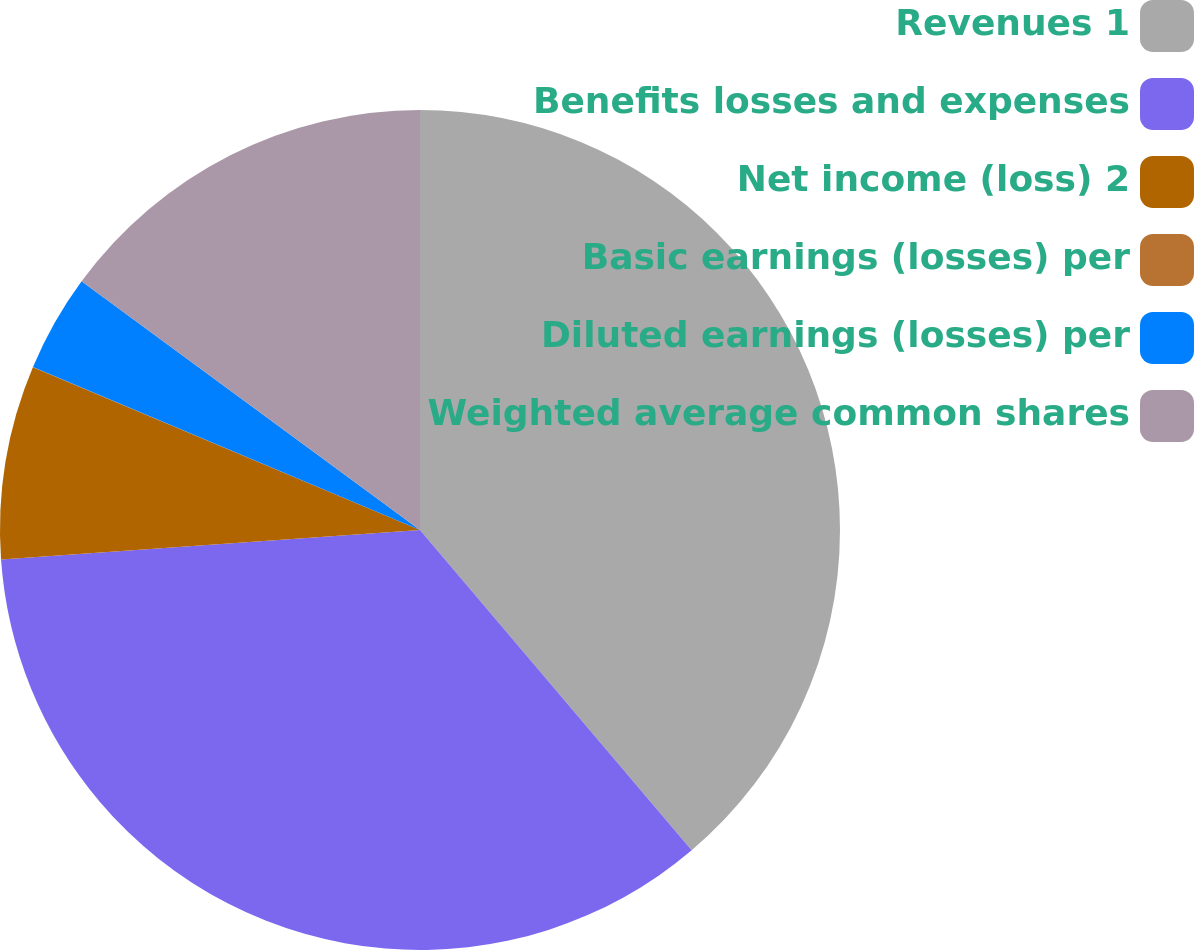Convert chart to OTSL. <chart><loc_0><loc_0><loc_500><loc_500><pie_chart><fcel>Revenues 1<fcel>Benefits losses and expenses<fcel>Net income (loss) 2<fcel>Basic earnings (losses) per<fcel>Diluted earnings (losses) per<fcel>Weighted average common shares<nl><fcel>38.8%<fcel>35.07%<fcel>7.46%<fcel>0.01%<fcel>3.74%<fcel>14.91%<nl></chart> 